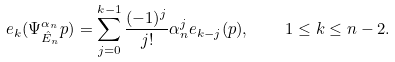<formula> <loc_0><loc_0><loc_500><loc_500>e _ { k } ( \Psi ^ { \alpha _ { n } } _ { \hat { E } _ { n } } p ) = \sum _ { j = 0 } ^ { k - 1 } \frac { ( - 1 ) ^ { j } } { j ! } \alpha _ { n } ^ { j } e _ { k - j } ( p ) , \quad 1 \leq k \leq n - 2 .</formula> 